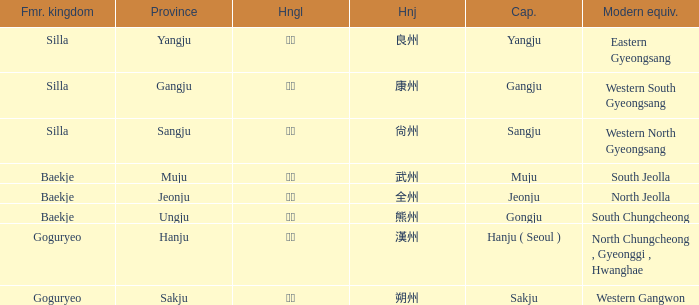What is the modern equivalent of the former kingdom "silla" with the hanja 尙州? 1.0. 